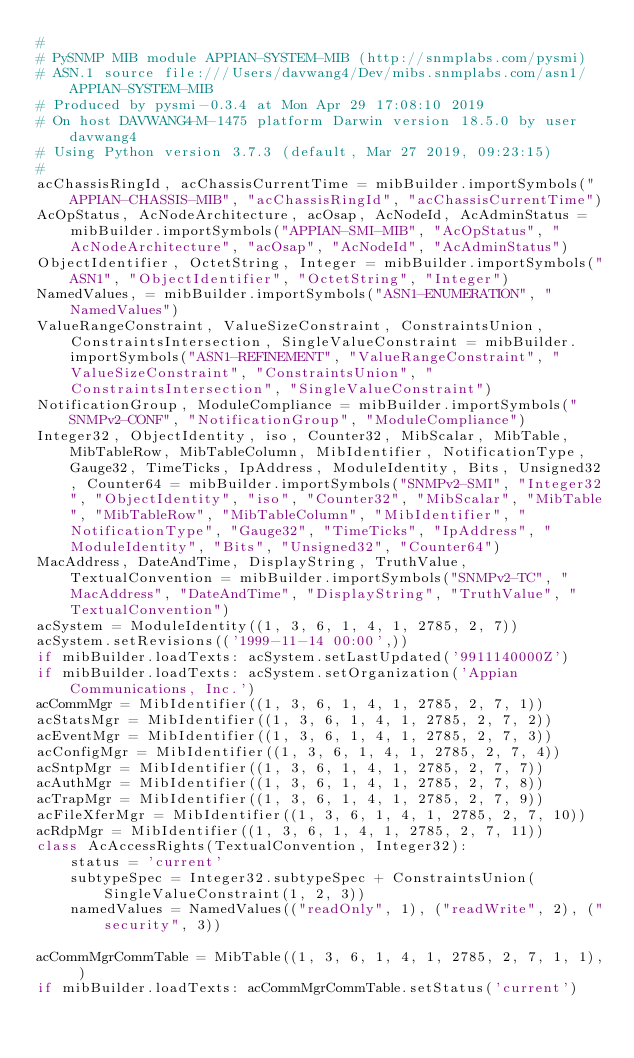<code> <loc_0><loc_0><loc_500><loc_500><_Python_>#
# PySNMP MIB module APPIAN-SYSTEM-MIB (http://snmplabs.com/pysmi)
# ASN.1 source file:///Users/davwang4/Dev/mibs.snmplabs.com/asn1/APPIAN-SYSTEM-MIB
# Produced by pysmi-0.3.4 at Mon Apr 29 17:08:10 2019
# On host DAVWANG4-M-1475 platform Darwin version 18.5.0 by user davwang4
# Using Python version 3.7.3 (default, Mar 27 2019, 09:23:15) 
#
acChassisRingId, acChassisCurrentTime = mibBuilder.importSymbols("APPIAN-CHASSIS-MIB", "acChassisRingId", "acChassisCurrentTime")
AcOpStatus, AcNodeArchitecture, acOsap, AcNodeId, AcAdminStatus = mibBuilder.importSymbols("APPIAN-SMI-MIB", "AcOpStatus", "AcNodeArchitecture", "acOsap", "AcNodeId", "AcAdminStatus")
ObjectIdentifier, OctetString, Integer = mibBuilder.importSymbols("ASN1", "ObjectIdentifier", "OctetString", "Integer")
NamedValues, = mibBuilder.importSymbols("ASN1-ENUMERATION", "NamedValues")
ValueRangeConstraint, ValueSizeConstraint, ConstraintsUnion, ConstraintsIntersection, SingleValueConstraint = mibBuilder.importSymbols("ASN1-REFINEMENT", "ValueRangeConstraint", "ValueSizeConstraint", "ConstraintsUnion", "ConstraintsIntersection", "SingleValueConstraint")
NotificationGroup, ModuleCompliance = mibBuilder.importSymbols("SNMPv2-CONF", "NotificationGroup", "ModuleCompliance")
Integer32, ObjectIdentity, iso, Counter32, MibScalar, MibTable, MibTableRow, MibTableColumn, MibIdentifier, NotificationType, Gauge32, TimeTicks, IpAddress, ModuleIdentity, Bits, Unsigned32, Counter64 = mibBuilder.importSymbols("SNMPv2-SMI", "Integer32", "ObjectIdentity", "iso", "Counter32", "MibScalar", "MibTable", "MibTableRow", "MibTableColumn", "MibIdentifier", "NotificationType", "Gauge32", "TimeTicks", "IpAddress", "ModuleIdentity", "Bits", "Unsigned32", "Counter64")
MacAddress, DateAndTime, DisplayString, TruthValue, TextualConvention = mibBuilder.importSymbols("SNMPv2-TC", "MacAddress", "DateAndTime", "DisplayString", "TruthValue", "TextualConvention")
acSystem = ModuleIdentity((1, 3, 6, 1, 4, 1, 2785, 2, 7))
acSystem.setRevisions(('1999-11-14 00:00',))
if mibBuilder.loadTexts: acSystem.setLastUpdated('9911140000Z')
if mibBuilder.loadTexts: acSystem.setOrganization('Appian Communications, Inc.')
acCommMgr = MibIdentifier((1, 3, 6, 1, 4, 1, 2785, 2, 7, 1))
acStatsMgr = MibIdentifier((1, 3, 6, 1, 4, 1, 2785, 2, 7, 2))
acEventMgr = MibIdentifier((1, 3, 6, 1, 4, 1, 2785, 2, 7, 3))
acConfigMgr = MibIdentifier((1, 3, 6, 1, 4, 1, 2785, 2, 7, 4))
acSntpMgr = MibIdentifier((1, 3, 6, 1, 4, 1, 2785, 2, 7, 7))
acAuthMgr = MibIdentifier((1, 3, 6, 1, 4, 1, 2785, 2, 7, 8))
acTrapMgr = MibIdentifier((1, 3, 6, 1, 4, 1, 2785, 2, 7, 9))
acFileXferMgr = MibIdentifier((1, 3, 6, 1, 4, 1, 2785, 2, 7, 10))
acRdpMgr = MibIdentifier((1, 3, 6, 1, 4, 1, 2785, 2, 7, 11))
class AcAccessRights(TextualConvention, Integer32):
    status = 'current'
    subtypeSpec = Integer32.subtypeSpec + ConstraintsUnion(SingleValueConstraint(1, 2, 3))
    namedValues = NamedValues(("readOnly", 1), ("readWrite", 2), ("security", 3))

acCommMgrCommTable = MibTable((1, 3, 6, 1, 4, 1, 2785, 2, 7, 1, 1), )
if mibBuilder.loadTexts: acCommMgrCommTable.setStatus('current')</code> 